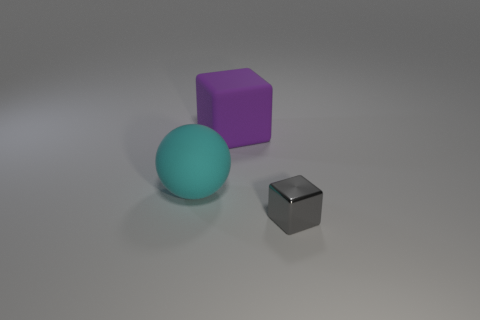Can you estimate the size of the objects based on visual cues? While it's challenging to provide exact measurements without a reference object, the objects can be tentatively compared to one another. The cube seems to have edges approximately 1.5 times longer than those of the smaller gray object, while the sphere's diameter appears roughly equal to the length of the cube's edge. 